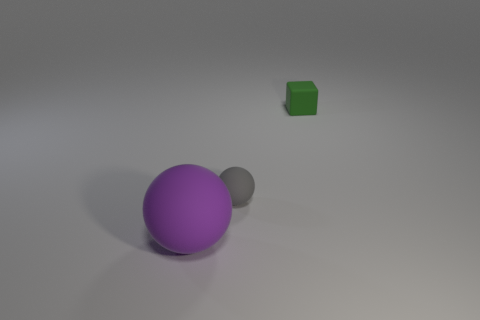The rubber object that is on the left side of the sphere right of the thing that is in front of the small matte ball is what color?
Your answer should be compact. Purple. Is the number of small rubber blocks that are in front of the small gray ball the same as the number of green cubes?
Make the answer very short. No. Is there a green thing that is behind the ball on the right side of the ball that is in front of the gray sphere?
Your response must be concise. Yes. Is the number of big balls on the right side of the green matte block less than the number of tiny cyan matte cylinders?
Your answer should be compact. No. How many other objects are the same shape as the big purple matte thing?
Offer a terse response. 1. What number of objects are either tiny rubber things that are to the right of the gray matte object or small blocks to the right of the purple matte sphere?
Give a very brief answer. 1. Does the rubber object that is to the left of the gray object have the same shape as the small green matte thing?
Provide a succinct answer. No. What is the size of the thing behind the rubber sphere behind the large sphere in front of the gray matte object?
Provide a succinct answer. Small. What number of things are either gray shiny cylinders or large balls?
Make the answer very short. 1. Do the big thing and the tiny rubber thing in front of the tiny green block have the same shape?
Ensure brevity in your answer.  Yes. 